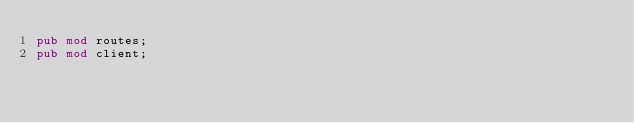Convert code to text. <code><loc_0><loc_0><loc_500><loc_500><_Rust_>pub mod routes;
pub mod client;</code> 